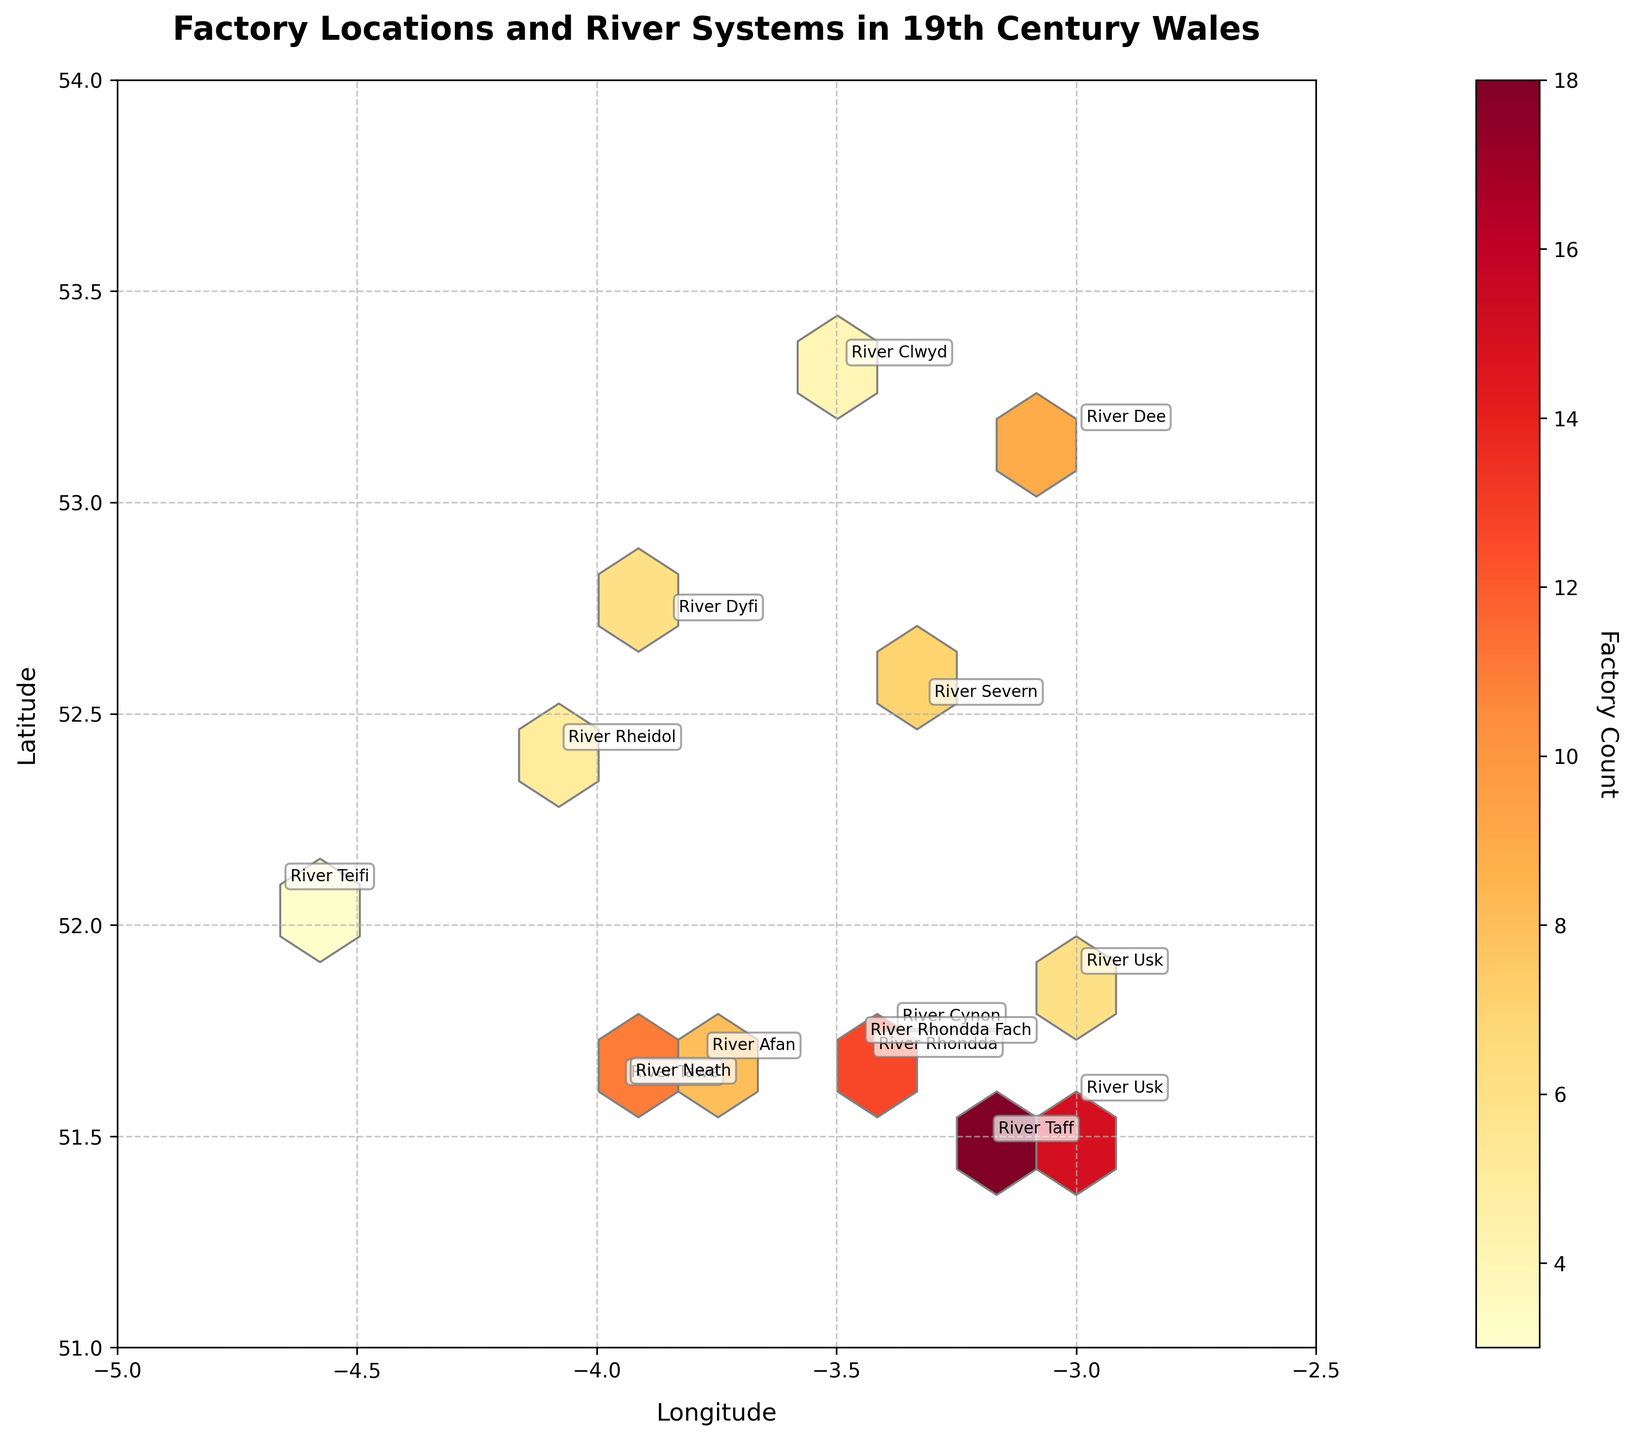What is the title of the hexbin plot? The title of the hexbin plot is displayed prominently at the top of the figure.
Answer: Factory Locations and River Systems in 19th Century Wales What do the x and y axes represent in the plot? The labels on the x and y axes indicate that the x-axis represents "Longitude" and the y-axis represents "Latitude."
Answer: Longitude and Latitude What does the color intensity in the hexagons represent? The color intensity of the hexagons correlates with the factory count, as indicated by the color bar labeled "Factory Count."
Answer: Factory Count Which river system has the highest number of factories located along it? By observing the annotations and the intensity of the hexagons, the River Taff has the highest number of factories.
Answer: River Taff How are the river systems annotated in the hexbin plot? The river systems are annotated with textual labels near their corresponding coordinates on the plot.
Answer: Textual labels How many river systems are represented in the figure? Count the unique river system names annotated on the figure. There are 15 annotations, each representing a unique river system.
Answer: 15 Which region appears to have the densest concentration of factories? The densest concentration of hexagons with dark colors, indicating a high factory count, is around the coordinates near (51.4833, -3.1833), which correlates with the River Taff area.
Answer: Coordinates near River Taff How many factory counts are associated with the River Tawe? Locate the annotation for the River Tawe and refer to the hexagon color intensity near (51.6167, -3.9500). The factory count for River Tawe is 12.
Answer: 12 Compare the factory counts between River Dee and River Severn. Which has more? By observing each river system's annotated coordinates, River Dee has a factory count of 9 and River Severn has a factory count of 7, so River Dee has more.
Answer: River Dee In terms of geographical coordinates, which river system is located furthest north? Observe the latitude values for each annotated river system. The River Clwyd at (53.3200, -3.4900) has the highest latitude, making it the furthest north.
Answer: River Clwyd 